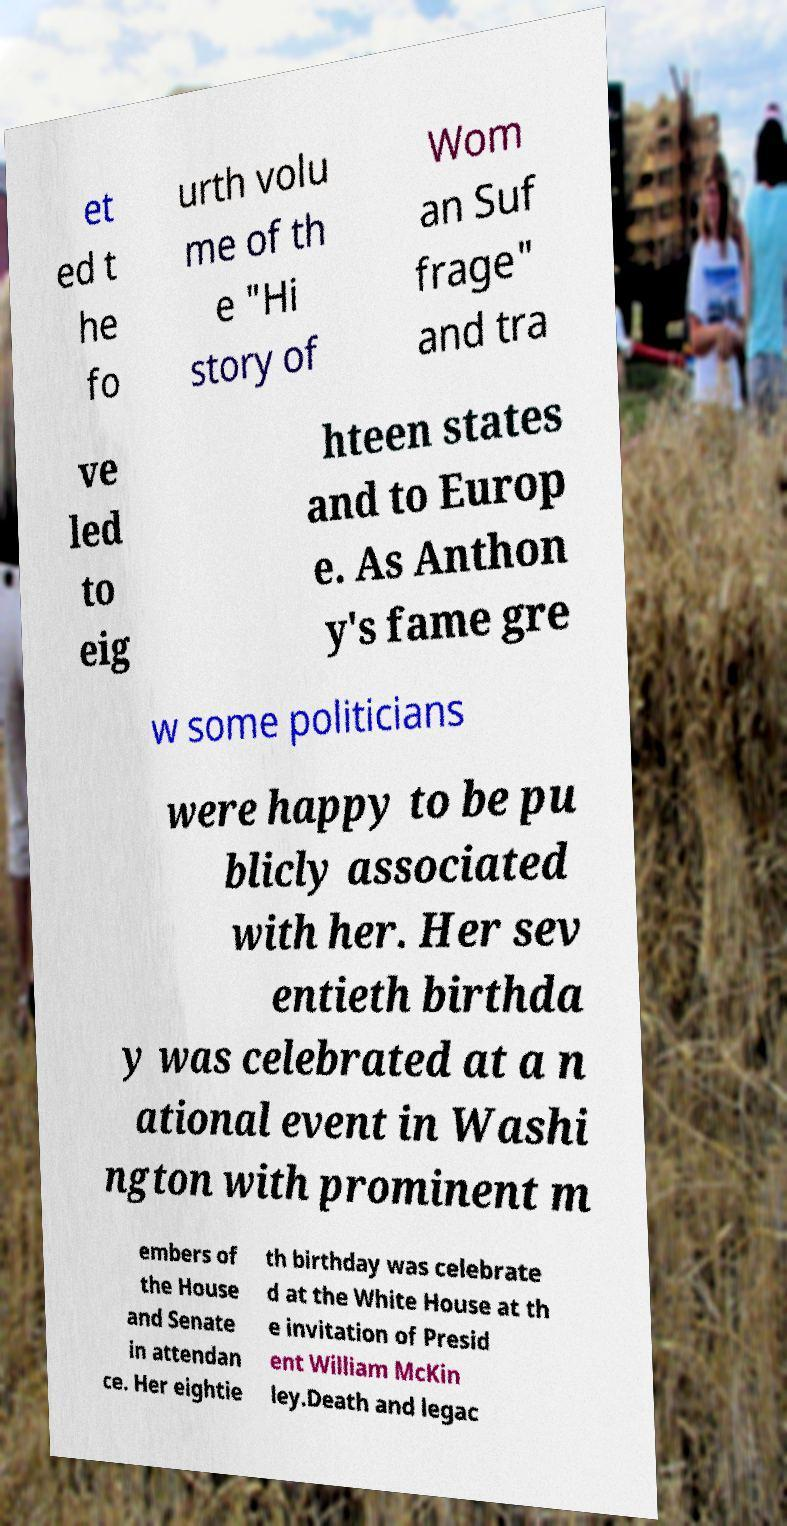Can you read and provide the text displayed in the image?This photo seems to have some interesting text. Can you extract and type it out for me? et ed t he fo urth volu me of th e "Hi story of Wom an Suf frage" and tra ve led to eig hteen states and to Europ e. As Anthon y's fame gre w some politicians were happy to be pu blicly associated with her. Her sev entieth birthda y was celebrated at a n ational event in Washi ngton with prominent m embers of the House and Senate in attendan ce. Her eightie th birthday was celebrate d at the White House at th e invitation of Presid ent William McKin ley.Death and legac 